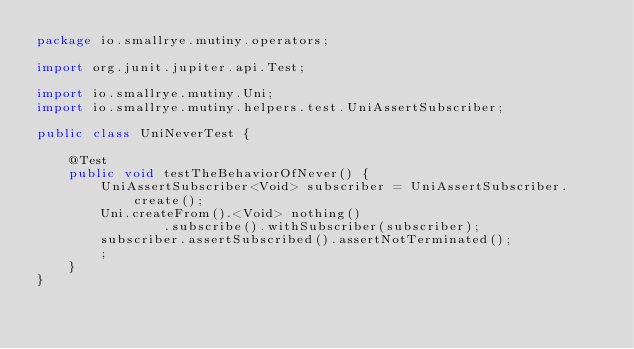<code> <loc_0><loc_0><loc_500><loc_500><_Java_>package io.smallrye.mutiny.operators;

import org.junit.jupiter.api.Test;

import io.smallrye.mutiny.Uni;
import io.smallrye.mutiny.helpers.test.UniAssertSubscriber;

public class UniNeverTest {

    @Test
    public void testTheBehaviorOfNever() {
        UniAssertSubscriber<Void> subscriber = UniAssertSubscriber.create();
        Uni.createFrom().<Void> nothing()
                .subscribe().withSubscriber(subscriber);
        subscriber.assertSubscribed().assertNotTerminated();
        ;
    }
}
</code> 